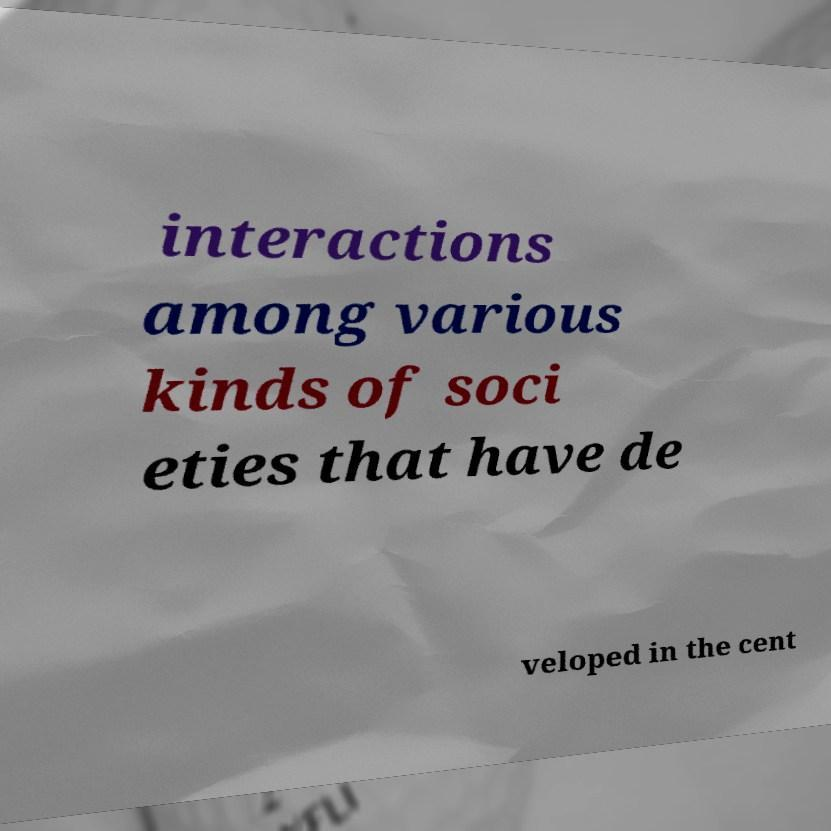For documentation purposes, I need the text within this image transcribed. Could you provide that? interactions among various kinds of soci eties that have de veloped in the cent 